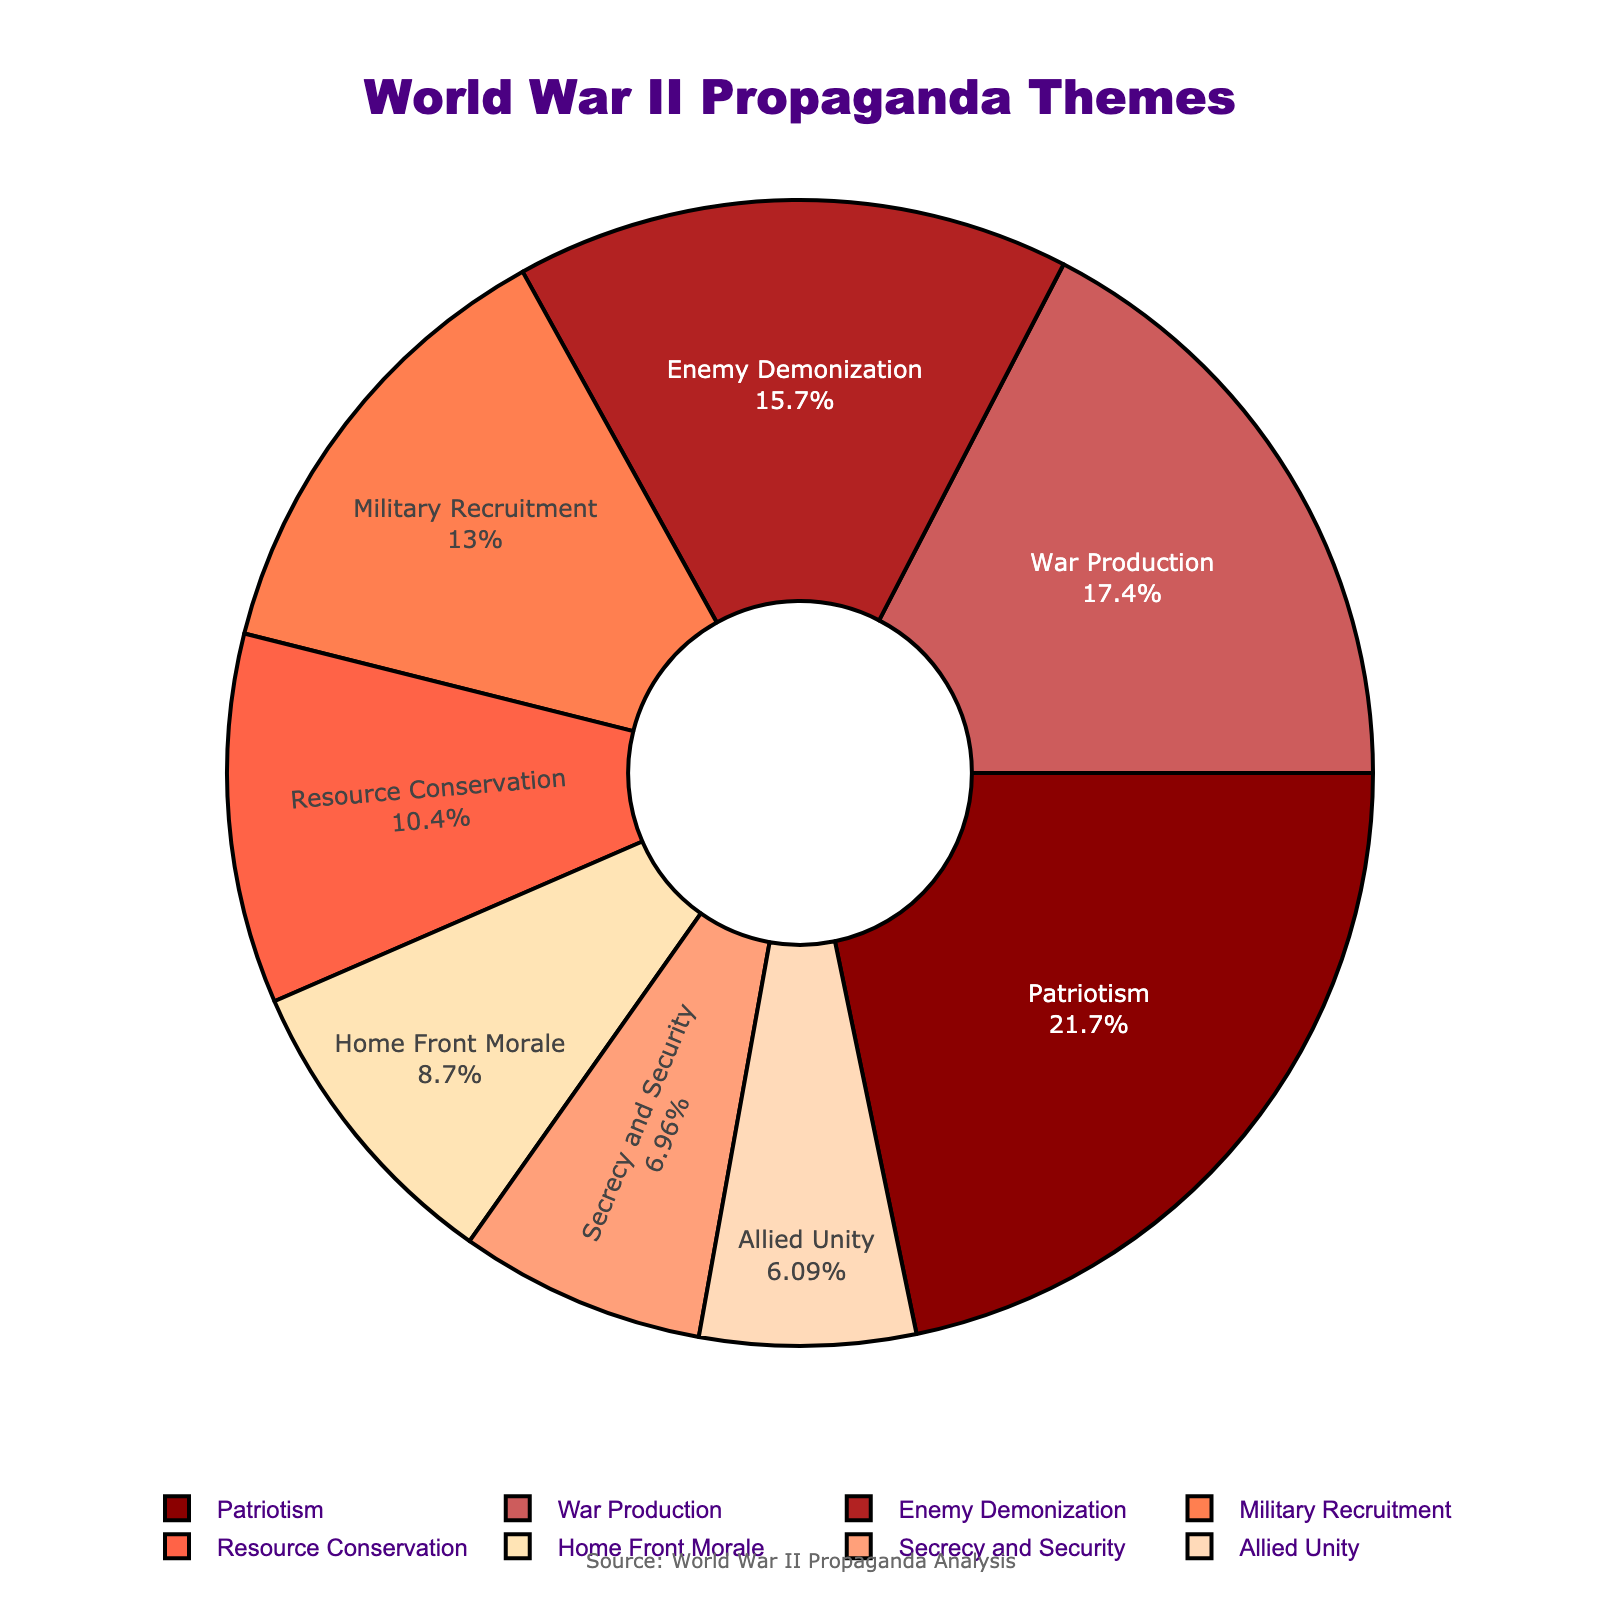What proportion of the posters focused on military recruitment? The pie chart shows "Military Recruitment" with a segment labeled "15%".
Answer: 15% Which theme had the smallest share of the posters and what was its percentage? The pie chart indicates that "Allied Unity" has the smallest share, labeled "7%".
Answer: Allied Unity, 7% How do the proportions of Patriotism and War Production compare? "Patriotism" has a segment labeled "25%", and "War Production" shows "20%". Comparing the two, Patriotism is greater than War Production.
Answer: Patriotism is greater What's the combined percentage of Enemy Demonization, Resource Conservation, and Secrecy and Security themes? Enemy Demonization is 18%, Resource Conservation is 12%, and Secrecy and Security is 8%. Summing them: 18% + 12% + 8% = 38%.
Answer: 38% Which theme precedes Home Front Morale counterclockwise on the chart and what is its percentage? Looking counterclockwise on the pie chart from "Home Front Morale" (10%), you reach "Secrecy and Security" (8%).
Answer: Secrecy and Security, 8% Are there more posters focused on War Production or a combination of Resource Conservation and Secrecy and Security? War Production is 20%, while the combination of Resource Conservation (12%) and Secrecy and Security (8%) is 20% (12% + 8%). Both sums are equal.
Answer: Equal What's the total percentage for themes other than Patriotism and Enemy Demonization? Subtract the sum of Patriotism (25%) and Enemy Demonization (18%) from 100%: 100% - (25% + 18%) = 57%.
Answer: 57% By examining color differences, which theme is represented by the lightest color? The color gradient shows "Allied Unity" with the lightest color.
Answer: Allied Unity In terms of percentage, what is the ratio of Home Front Morale to Secrecy and Security? Home Front Morale is 10% and Secrecy and Security is 8%, so the ratio is 10%/8% = 1.25.
Answer: 1.25 Which theme's segment is closest to a fifth of the entire pie chart? A fifth is 20%. "War Production" is labeled as 20%, which is closest to a fifth.
Answer: War Production 